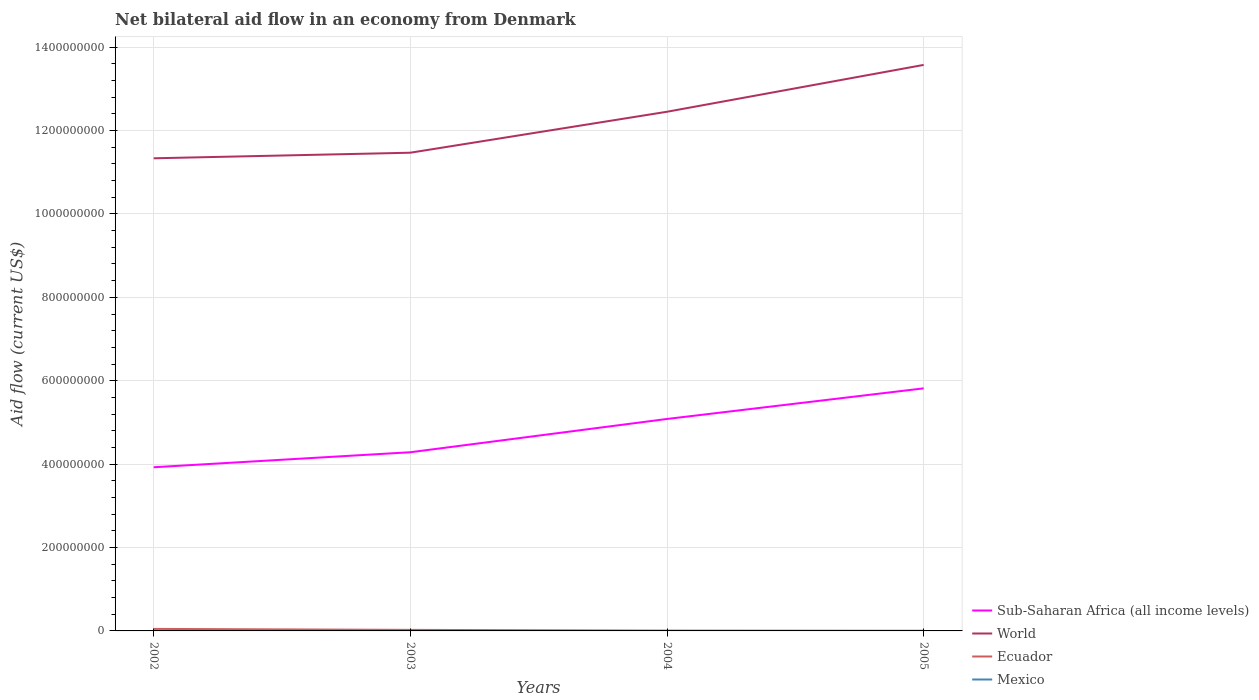How many different coloured lines are there?
Make the answer very short. 3. Across all years, what is the maximum net bilateral aid flow in Mexico?
Provide a short and direct response. 0. What is the total net bilateral aid flow in World in the graph?
Give a very brief answer. -2.11e+08. What is the difference between the highest and the second highest net bilateral aid flow in Sub-Saharan Africa (all income levels)?
Offer a terse response. 1.89e+08. What is the difference between the highest and the lowest net bilateral aid flow in World?
Offer a terse response. 2. Are the values on the major ticks of Y-axis written in scientific E-notation?
Your answer should be compact. No. Does the graph contain grids?
Your answer should be very brief. Yes. Where does the legend appear in the graph?
Keep it short and to the point. Bottom right. What is the title of the graph?
Your response must be concise. Net bilateral aid flow in an economy from Denmark. Does "Middle income" appear as one of the legend labels in the graph?
Make the answer very short. No. What is the label or title of the Y-axis?
Ensure brevity in your answer.  Aid flow (current US$). What is the Aid flow (current US$) in Sub-Saharan Africa (all income levels) in 2002?
Your response must be concise. 3.93e+08. What is the Aid flow (current US$) of World in 2002?
Provide a short and direct response. 1.13e+09. What is the Aid flow (current US$) in Ecuador in 2002?
Give a very brief answer. 4.83e+06. What is the Aid flow (current US$) in Mexico in 2002?
Ensure brevity in your answer.  0. What is the Aid flow (current US$) in Sub-Saharan Africa (all income levels) in 2003?
Provide a short and direct response. 4.29e+08. What is the Aid flow (current US$) of World in 2003?
Ensure brevity in your answer.  1.15e+09. What is the Aid flow (current US$) in Ecuador in 2003?
Provide a short and direct response. 2.50e+06. What is the Aid flow (current US$) of Mexico in 2003?
Provide a succinct answer. 0. What is the Aid flow (current US$) of Sub-Saharan Africa (all income levels) in 2004?
Give a very brief answer. 5.08e+08. What is the Aid flow (current US$) in World in 2004?
Offer a very short reply. 1.25e+09. What is the Aid flow (current US$) in Ecuador in 2004?
Keep it short and to the point. 7.30e+05. What is the Aid flow (current US$) in Sub-Saharan Africa (all income levels) in 2005?
Give a very brief answer. 5.82e+08. What is the Aid flow (current US$) of World in 2005?
Give a very brief answer. 1.36e+09. Across all years, what is the maximum Aid flow (current US$) in Sub-Saharan Africa (all income levels)?
Offer a very short reply. 5.82e+08. Across all years, what is the maximum Aid flow (current US$) in World?
Your response must be concise. 1.36e+09. Across all years, what is the maximum Aid flow (current US$) in Ecuador?
Your response must be concise. 4.83e+06. Across all years, what is the minimum Aid flow (current US$) in Sub-Saharan Africa (all income levels)?
Give a very brief answer. 3.93e+08. Across all years, what is the minimum Aid flow (current US$) in World?
Give a very brief answer. 1.13e+09. What is the total Aid flow (current US$) in Sub-Saharan Africa (all income levels) in the graph?
Provide a succinct answer. 1.91e+09. What is the total Aid flow (current US$) of World in the graph?
Your answer should be compact. 4.88e+09. What is the total Aid flow (current US$) of Ecuador in the graph?
Your response must be concise. 8.51e+06. What is the difference between the Aid flow (current US$) in Sub-Saharan Africa (all income levels) in 2002 and that in 2003?
Provide a succinct answer. -3.60e+07. What is the difference between the Aid flow (current US$) of World in 2002 and that in 2003?
Offer a very short reply. -1.34e+07. What is the difference between the Aid flow (current US$) of Ecuador in 2002 and that in 2003?
Ensure brevity in your answer.  2.33e+06. What is the difference between the Aid flow (current US$) in Sub-Saharan Africa (all income levels) in 2002 and that in 2004?
Make the answer very short. -1.16e+08. What is the difference between the Aid flow (current US$) of World in 2002 and that in 2004?
Offer a very short reply. -1.12e+08. What is the difference between the Aid flow (current US$) in Ecuador in 2002 and that in 2004?
Keep it short and to the point. 4.10e+06. What is the difference between the Aid flow (current US$) of Sub-Saharan Africa (all income levels) in 2002 and that in 2005?
Your answer should be very brief. -1.89e+08. What is the difference between the Aid flow (current US$) in World in 2002 and that in 2005?
Offer a very short reply. -2.24e+08. What is the difference between the Aid flow (current US$) of Ecuador in 2002 and that in 2005?
Provide a short and direct response. 4.38e+06. What is the difference between the Aid flow (current US$) of Sub-Saharan Africa (all income levels) in 2003 and that in 2004?
Provide a succinct answer. -7.98e+07. What is the difference between the Aid flow (current US$) in World in 2003 and that in 2004?
Provide a succinct answer. -9.82e+07. What is the difference between the Aid flow (current US$) in Ecuador in 2003 and that in 2004?
Provide a short and direct response. 1.77e+06. What is the difference between the Aid flow (current US$) in Sub-Saharan Africa (all income levels) in 2003 and that in 2005?
Your answer should be compact. -1.53e+08. What is the difference between the Aid flow (current US$) of World in 2003 and that in 2005?
Provide a succinct answer. -2.11e+08. What is the difference between the Aid flow (current US$) in Ecuador in 2003 and that in 2005?
Give a very brief answer. 2.05e+06. What is the difference between the Aid flow (current US$) of Sub-Saharan Africa (all income levels) in 2004 and that in 2005?
Provide a succinct answer. -7.34e+07. What is the difference between the Aid flow (current US$) in World in 2004 and that in 2005?
Ensure brevity in your answer.  -1.12e+08. What is the difference between the Aid flow (current US$) in Ecuador in 2004 and that in 2005?
Offer a terse response. 2.80e+05. What is the difference between the Aid flow (current US$) of Sub-Saharan Africa (all income levels) in 2002 and the Aid flow (current US$) of World in 2003?
Give a very brief answer. -7.54e+08. What is the difference between the Aid flow (current US$) of Sub-Saharan Africa (all income levels) in 2002 and the Aid flow (current US$) of Ecuador in 2003?
Give a very brief answer. 3.90e+08. What is the difference between the Aid flow (current US$) of World in 2002 and the Aid flow (current US$) of Ecuador in 2003?
Offer a very short reply. 1.13e+09. What is the difference between the Aid flow (current US$) of Sub-Saharan Africa (all income levels) in 2002 and the Aid flow (current US$) of World in 2004?
Keep it short and to the point. -8.53e+08. What is the difference between the Aid flow (current US$) of Sub-Saharan Africa (all income levels) in 2002 and the Aid flow (current US$) of Ecuador in 2004?
Keep it short and to the point. 3.92e+08. What is the difference between the Aid flow (current US$) in World in 2002 and the Aid flow (current US$) in Ecuador in 2004?
Your answer should be compact. 1.13e+09. What is the difference between the Aid flow (current US$) of Sub-Saharan Africa (all income levels) in 2002 and the Aid flow (current US$) of World in 2005?
Provide a succinct answer. -9.65e+08. What is the difference between the Aid flow (current US$) of Sub-Saharan Africa (all income levels) in 2002 and the Aid flow (current US$) of Ecuador in 2005?
Offer a terse response. 3.92e+08. What is the difference between the Aid flow (current US$) in World in 2002 and the Aid flow (current US$) in Ecuador in 2005?
Keep it short and to the point. 1.13e+09. What is the difference between the Aid flow (current US$) in Sub-Saharan Africa (all income levels) in 2003 and the Aid flow (current US$) in World in 2004?
Your response must be concise. -8.17e+08. What is the difference between the Aid flow (current US$) of Sub-Saharan Africa (all income levels) in 2003 and the Aid flow (current US$) of Ecuador in 2004?
Your response must be concise. 4.28e+08. What is the difference between the Aid flow (current US$) in World in 2003 and the Aid flow (current US$) in Ecuador in 2004?
Ensure brevity in your answer.  1.15e+09. What is the difference between the Aid flow (current US$) in Sub-Saharan Africa (all income levels) in 2003 and the Aid flow (current US$) in World in 2005?
Your answer should be very brief. -9.29e+08. What is the difference between the Aid flow (current US$) in Sub-Saharan Africa (all income levels) in 2003 and the Aid flow (current US$) in Ecuador in 2005?
Ensure brevity in your answer.  4.28e+08. What is the difference between the Aid flow (current US$) of World in 2003 and the Aid flow (current US$) of Ecuador in 2005?
Make the answer very short. 1.15e+09. What is the difference between the Aid flow (current US$) of Sub-Saharan Africa (all income levels) in 2004 and the Aid flow (current US$) of World in 2005?
Give a very brief answer. -8.49e+08. What is the difference between the Aid flow (current US$) in Sub-Saharan Africa (all income levels) in 2004 and the Aid flow (current US$) in Ecuador in 2005?
Provide a succinct answer. 5.08e+08. What is the difference between the Aid flow (current US$) in World in 2004 and the Aid flow (current US$) in Ecuador in 2005?
Provide a short and direct response. 1.24e+09. What is the average Aid flow (current US$) in Sub-Saharan Africa (all income levels) per year?
Make the answer very short. 4.78e+08. What is the average Aid flow (current US$) in World per year?
Offer a very short reply. 1.22e+09. What is the average Aid flow (current US$) of Ecuador per year?
Your response must be concise. 2.13e+06. In the year 2002, what is the difference between the Aid flow (current US$) in Sub-Saharan Africa (all income levels) and Aid flow (current US$) in World?
Provide a succinct answer. -7.41e+08. In the year 2002, what is the difference between the Aid flow (current US$) of Sub-Saharan Africa (all income levels) and Aid flow (current US$) of Ecuador?
Give a very brief answer. 3.88e+08. In the year 2002, what is the difference between the Aid flow (current US$) in World and Aid flow (current US$) in Ecuador?
Offer a very short reply. 1.13e+09. In the year 2003, what is the difference between the Aid flow (current US$) of Sub-Saharan Africa (all income levels) and Aid flow (current US$) of World?
Offer a very short reply. -7.18e+08. In the year 2003, what is the difference between the Aid flow (current US$) of Sub-Saharan Africa (all income levels) and Aid flow (current US$) of Ecuador?
Offer a terse response. 4.26e+08. In the year 2003, what is the difference between the Aid flow (current US$) of World and Aid flow (current US$) of Ecuador?
Your response must be concise. 1.14e+09. In the year 2004, what is the difference between the Aid flow (current US$) in Sub-Saharan Africa (all income levels) and Aid flow (current US$) in World?
Provide a succinct answer. -7.37e+08. In the year 2004, what is the difference between the Aid flow (current US$) of Sub-Saharan Africa (all income levels) and Aid flow (current US$) of Ecuador?
Offer a very short reply. 5.08e+08. In the year 2004, what is the difference between the Aid flow (current US$) of World and Aid flow (current US$) of Ecuador?
Offer a very short reply. 1.24e+09. In the year 2005, what is the difference between the Aid flow (current US$) in Sub-Saharan Africa (all income levels) and Aid flow (current US$) in World?
Give a very brief answer. -7.76e+08. In the year 2005, what is the difference between the Aid flow (current US$) of Sub-Saharan Africa (all income levels) and Aid flow (current US$) of Ecuador?
Offer a terse response. 5.81e+08. In the year 2005, what is the difference between the Aid flow (current US$) in World and Aid flow (current US$) in Ecuador?
Your answer should be very brief. 1.36e+09. What is the ratio of the Aid flow (current US$) in Sub-Saharan Africa (all income levels) in 2002 to that in 2003?
Your response must be concise. 0.92. What is the ratio of the Aid flow (current US$) in World in 2002 to that in 2003?
Your response must be concise. 0.99. What is the ratio of the Aid flow (current US$) of Ecuador in 2002 to that in 2003?
Ensure brevity in your answer.  1.93. What is the ratio of the Aid flow (current US$) of Sub-Saharan Africa (all income levels) in 2002 to that in 2004?
Make the answer very short. 0.77. What is the ratio of the Aid flow (current US$) in World in 2002 to that in 2004?
Your response must be concise. 0.91. What is the ratio of the Aid flow (current US$) in Ecuador in 2002 to that in 2004?
Your answer should be compact. 6.62. What is the ratio of the Aid flow (current US$) in Sub-Saharan Africa (all income levels) in 2002 to that in 2005?
Provide a short and direct response. 0.67. What is the ratio of the Aid flow (current US$) of World in 2002 to that in 2005?
Your answer should be compact. 0.83. What is the ratio of the Aid flow (current US$) in Ecuador in 2002 to that in 2005?
Offer a terse response. 10.73. What is the ratio of the Aid flow (current US$) of Sub-Saharan Africa (all income levels) in 2003 to that in 2004?
Your response must be concise. 0.84. What is the ratio of the Aid flow (current US$) in World in 2003 to that in 2004?
Offer a very short reply. 0.92. What is the ratio of the Aid flow (current US$) of Ecuador in 2003 to that in 2004?
Your answer should be compact. 3.42. What is the ratio of the Aid flow (current US$) in Sub-Saharan Africa (all income levels) in 2003 to that in 2005?
Your answer should be compact. 0.74. What is the ratio of the Aid flow (current US$) of World in 2003 to that in 2005?
Keep it short and to the point. 0.84. What is the ratio of the Aid flow (current US$) of Ecuador in 2003 to that in 2005?
Ensure brevity in your answer.  5.56. What is the ratio of the Aid flow (current US$) in Sub-Saharan Africa (all income levels) in 2004 to that in 2005?
Ensure brevity in your answer.  0.87. What is the ratio of the Aid flow (current US$) in World in 2004 to that in 2005?
Your answer should be very brief. 0.92. What is the ratio of the Aid flow (current US$) in Ecuador in 2004 to that in 2005?
Offer a terse response. 1.62. What is the difference between the highest and the second highest Aid flow (current US$) in Sub-Saharan Africa (all income levels)?
Your answer should be very brief. 7.34e+07. What is the difference between the highest and the second highest Aid flow (current US$) in World?
Your answer should be very brief. 1.12e+08. What is the difference between the highest and the second highest Aid flow (current US$) in Ecuador?
Your answer should be compact. 2.33e+06. What is the difference between the highest and the lowest Aid flow (current US$) in Sub-Saharan Africa (all income levels)?
Offer a very short reply. 1.89e+08. What is the difference between the highest and the lowest Aid flow (current US$) of World?
Keep it short and to the point. 2.24e+08. What is the difference between the highest and the lowest Aid flow (current US$) in Ecuador?
Keep it short and to the point. 4.38e+06. 